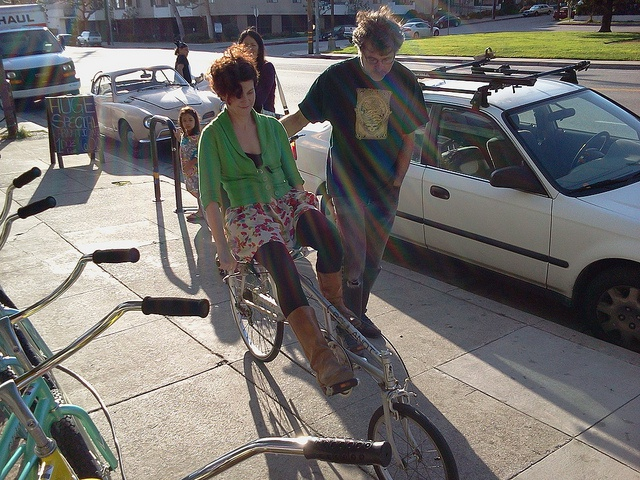Describe the objects in this image and their specific colors. I can see car in gray, black, and darkgray tones, people in gray, black, maroon, and darkgreen tones, people in gray and black tones, bicycle in gray, black, and darkgray tones, and bicycle in gray, black, teal, and lightgray tones in this image. 